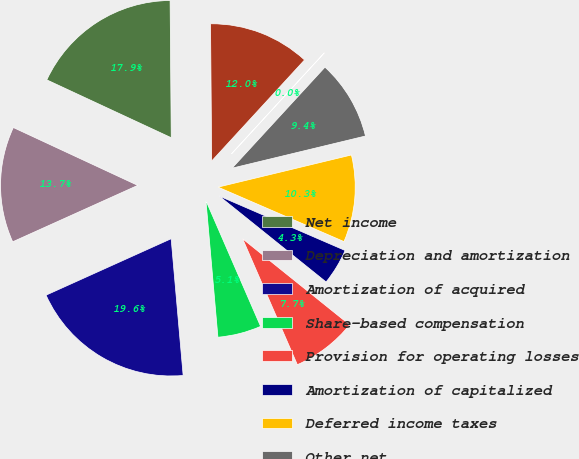Convert chart to OTSL. <chart><loc_0><loc_0><loc_500><loc_500><pie_chart><fcel>Net income<fcel>Depreciation and amortization<fcel>Amortization of acquired<fcel>Share-based compensation<fcel>Provision for operating losses<fcel>Amortization of capitalized<fcel>Deferred income taxes<fcel>Other net<fcel>Accounts receivable<fcel>Settlement processing assets<nl><fcel>17.94%<fcel>13.67%<fcel>19.65%<fcel>5.13%<fcel>7.7%<fcel>4.28%<fcel>10.26%<fcel>9.4%<fcel>0.01%<fcel>11.96%<nl></chart> 